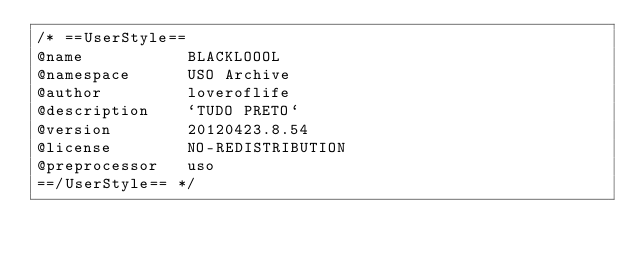<code> <loc_0><loc_0><loc_500><loc_500><_CSS_>/* ==UserStyle==
@name           BLACKLOOOL
@namespace      USO Archive
@author         loveroflife
@description    `TUDO PRETO`
@version        20120423.8.54
@license        NO-REDISTRIBUTION
@preprocessor   uso
==/UserStyle== */</code> 